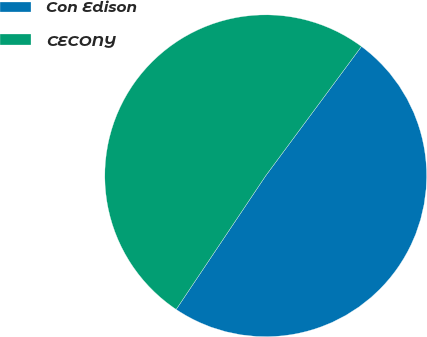Convert chart. <chart><loc_0><loc_0><loc_500><loc_500><pie_chart><fcel>Con Edison<fcel>CECONY<nl><fcel>49.25%<fcel>50.75%<nl></chart> 